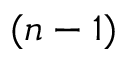Convert formula to latex. <formula><loc_0><loc_0><loc_500><loc_500>( n - 1 )</formula> 